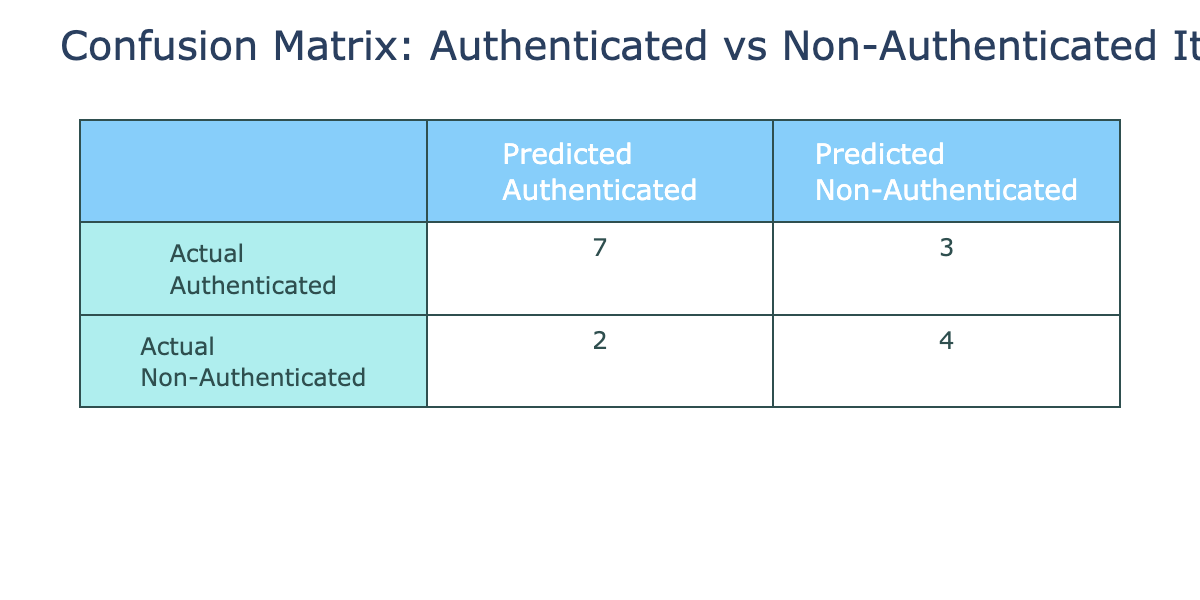What is the number of times authenticated items were predicted as authenticated? In the table, we look at the intersection of 'Actual Authenticated' and 'Predicted Authenticated'. This value is 8.
Answer: 8 What is the number of times non-authenticated items were predicted correctly? We check the intersection of 'Actual Non-Authenticated' and 'Predicted Non-Authenticated'. This value is 5.
Answer: 5 How many total items were classified as non-authenticated? To find this, we need to sum the values in the 'Predicted Non-Authenticated' column: 3 (from actual authenticated) and 5 (from actual non-authenticated), totaling 8.
Answer: 8 What is the total number of predictions made? We count all values in the confusion matrix, which are: 8 (true positives) + 5 (true negatives) + 3 (false negatives) + 4 (false positives) = 20.
Answer: 20 Were any authenticated items predicted as non-authenticated? Yes, we look in the 'Predicted Non-Authenticated' corresponding to 'Actual Authenticated'. There are 3 such cases.
Answer: Yes Was there a greater number of correct predictions for authenticated items than for non-authenticated items? For authenticated items, there are 8 correct predictions. For non-authenticated items, there are 5 correct predictions. Since 8 > 5, the answer is yes.
Answer: Yes What is the total number of incorrect predictions? The incorrect predictions consist of false positives and false negatives. From the table: 4 (false positives) + 3 (false negatives) gives a total of 7 incorrect predictions.
Answer: 7 What percentage of the items were authenticated? To find this, use the total number of items 20. The number of authenticated items is 13 (8 true positives + 5 false negatives). Thus, the percentage is (13/20) * 100 = 65%.
Answer: 65% Which group had a better prediction rate: authenticated or non-authenticated items? The prediction rate for authenticated items is 8 out of 11 (8 correct out of 11 total), which is about 72.73%. For non-authenticated items, it is 5 out of 9, which is about 55.56%. Since 72.73% > 55.56%, authenticated items had a better prediction rate.
Answer: Authenticated items 